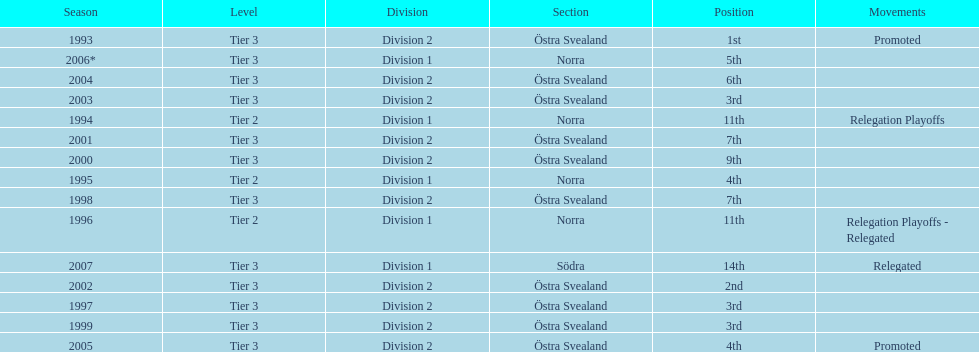In division 2 tier 3, how many instances were there when they finished over 5th place? 6. 